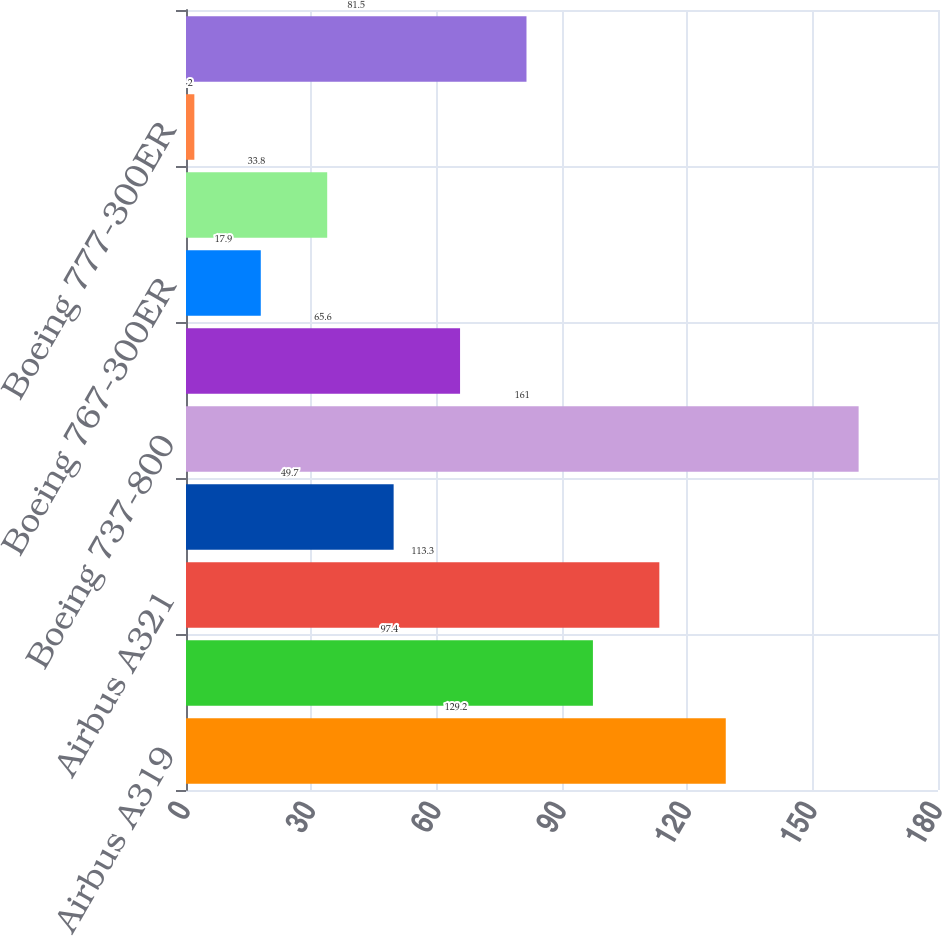Convert chart to OTSL. <chart><loc_0><loc_0><loc_500><loc_500><bar_chart><fcel>Airbus A319<fcel>Airbus A320<fcel>Airbus A321<fcel>Airbus A330-300<fcel>Boeing 737-800<fcel>Boeing 757-200<fcel>Boeing 767-300ER<fcel>Boeing 777-200ER<fcel>Boeing 777-300ER<fcel>McDonnell Douglas MD-80<nl><fcel>129.2<fcel>97.4<fcel>113.3<fcel>49.7<fcel>161<fcel>65.6<fcel>17.9<fcel>33.8<fcel>2<fcel>81.5<nl></chart> 